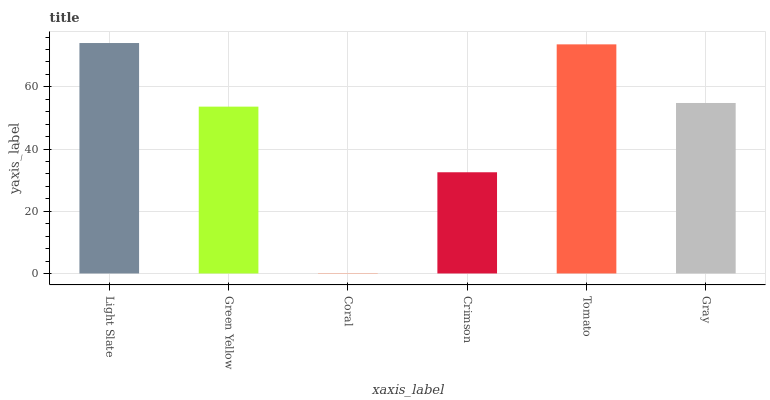Is Coral the minimum?
Answer yes or no. Yes. Is Light Slate the maximum?
Answer yes or no. Yes. Is Green Yellow the minimum?
Answer yes or no. No. Is Green Yellow the maximum?
Answer yes or no. No. Is Light Slate greater than Green Yellow?
Answer yes or no. Yes. Is Green Yellow less than Light Slate?
Answer yes or no. Yes. Is Green Yellow greater than Light Slate?
Answer yes or no. No. Is Light Slate less than Green Yellow?
Answer yes or no. No. Is Gray the high median?
Answer yes or no. Yes. Is Green Yellow the low median?
Answer yes or no. Yes. Is Green Yellow the high median?
Answer yes or no. No. Is Light Slate the low median?
Answer yes or no. No. 